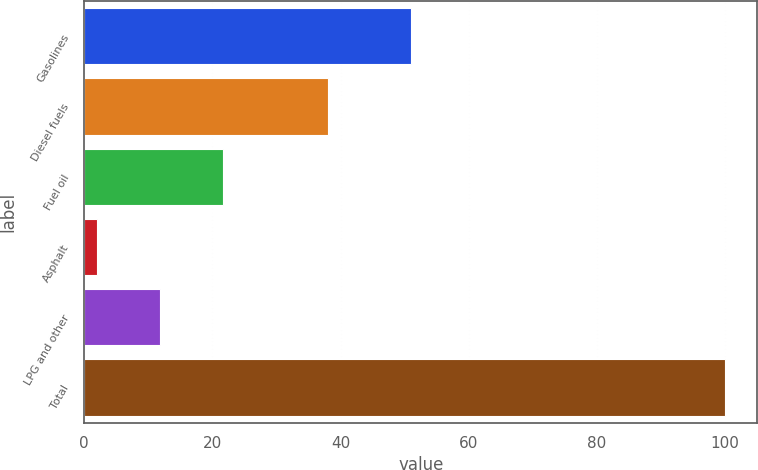Convert chart to OTSL. <chart><loc_0><loc_0><loc_500><loc_500><bar_chart><fcel>Gasolines<fcel>Diesel fuels<fcel>Fuel oil<fcel>Asphalt<fcel>LPG and other<fcel>Total<nl><fcel>51<fcel>38<fcel>21.6<fcel>2<fcel>11.8<fcel>100<nl></chart> 